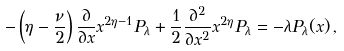Convert formula to latex. <formula><loc_0><loc_0><loc_500><loc_500>- \left ( \eta - \frac { \nu } { 2 } \right ) \frac { \partial } { \partial x } x ^ { 2 \eta - 1 } P _ { \lambda } + \frac { 1 } { 2 } \frac { \partial ^ { 2 } } { \partial x ^ { 2 } } x ^ { 2 \eta } P _ { \lambda } = - \lambda P _ { \lambda } ( x ) \, ,</formula> 